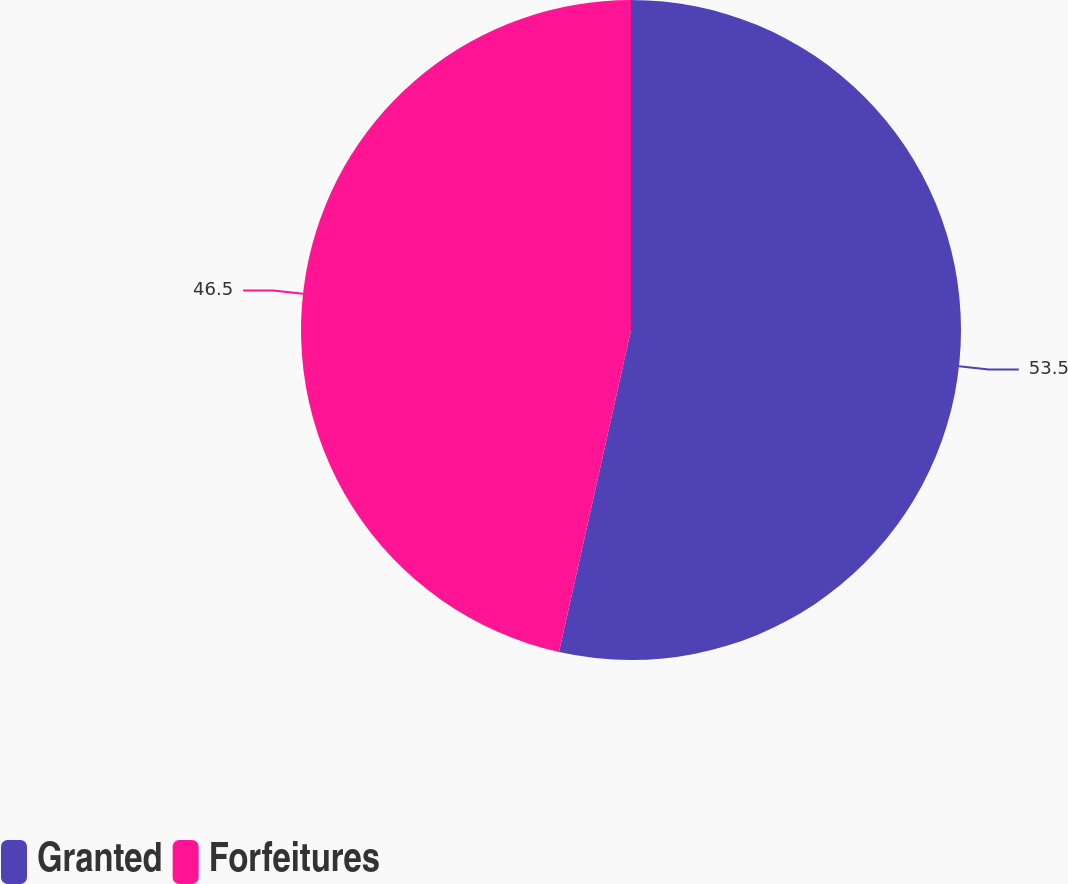<chart> <loc_0><loc_0><loc_500><loc_500><pie_chart><fcel>Granted<fcel>Forfeitures<nl><fcel>53.5%<fcel>46.5%<nl></chart> 